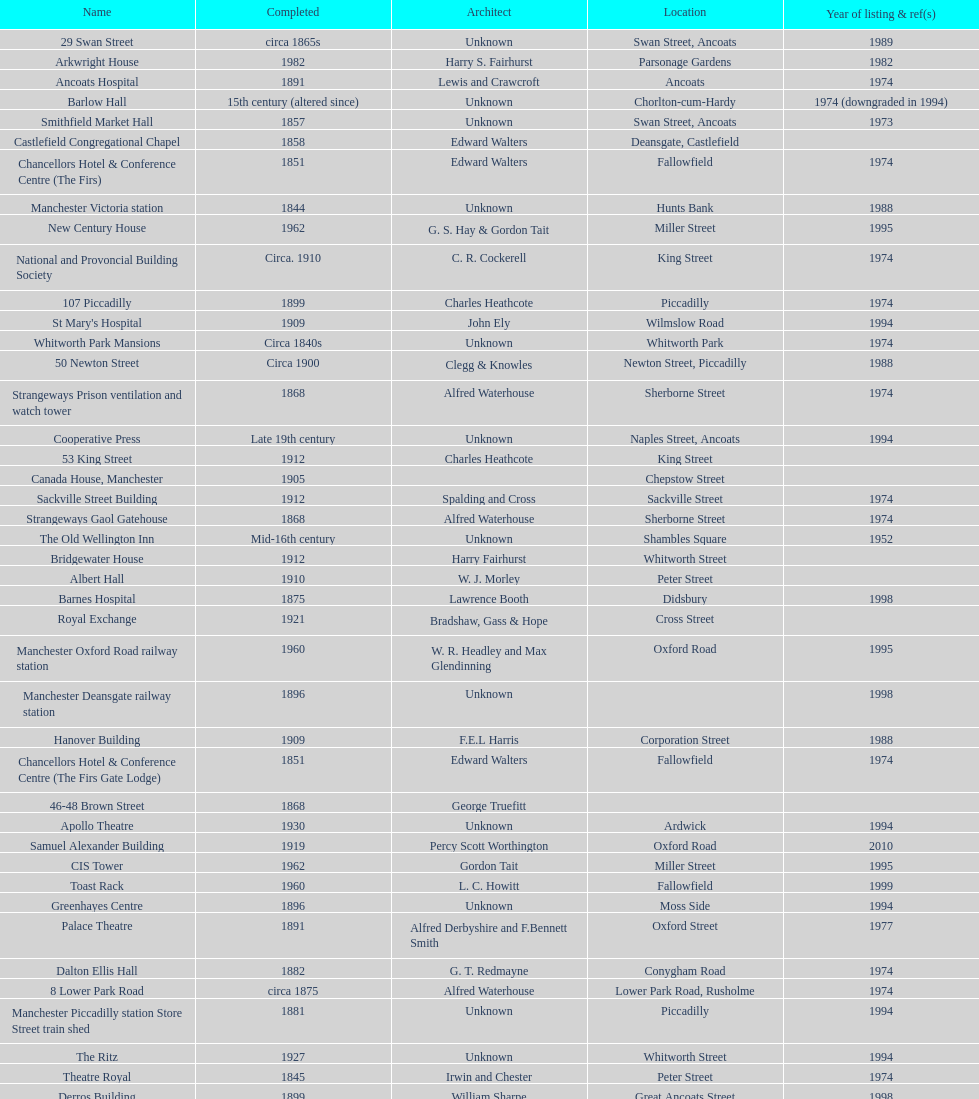How many buildings has the same year of listing as 1974? 15. 